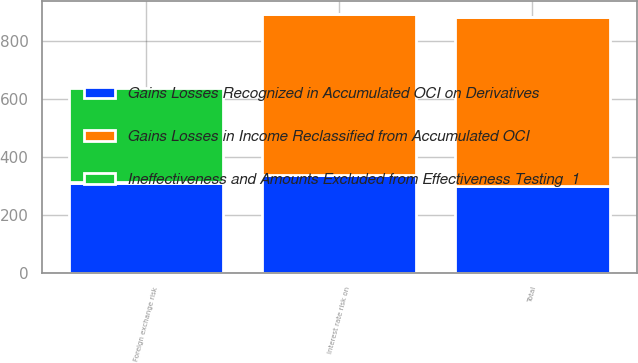Convert chart to OTSL. <chart><loc_0><loc_0><loc_500><loc_500><stacked_bar_chart><ecel><fcel>Interest rate risk on<fcel>Total<fcel>Foreign exchange risk<nl><fcel>Gains Losses Recognized in Accumulated OCI on Derivatives<fcel>340<fcel>299<fcel>312<nl><fcel>Gains Losses in Income Reclassified from Accumulated OCI<fcel>553<fcel>585<fcel>3<nl><fcel>Ineffectiveness and Amounts Excluded from Effectiveness Testing  1<fcel>1<fcel>1<fcel>325<nl></chart> 